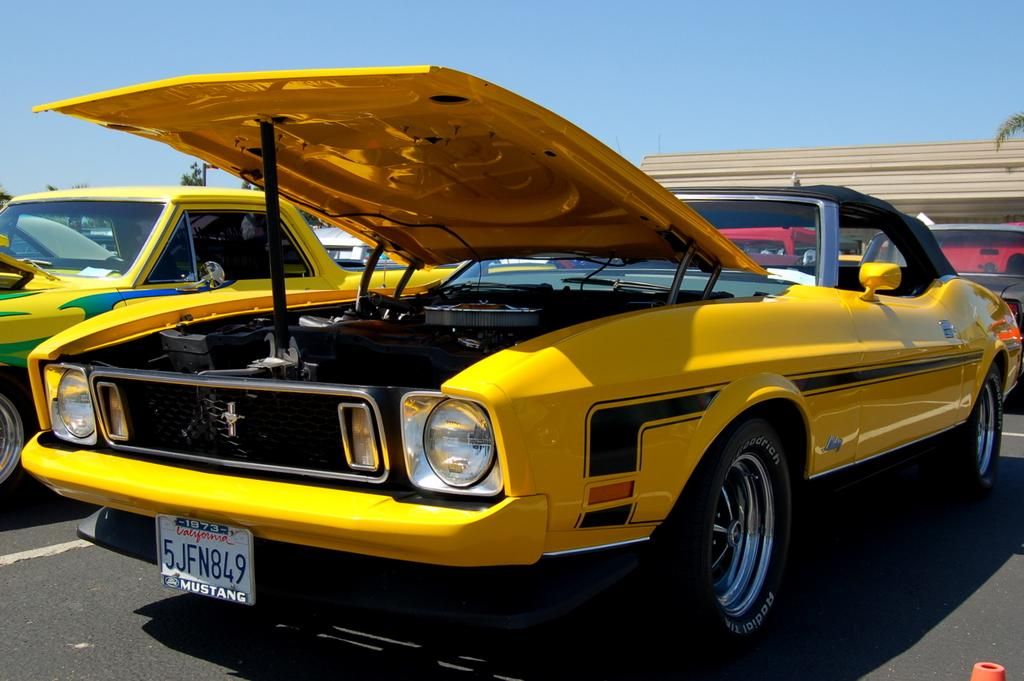<image>
Describe the image concisely. A yellow mustang with a 1973 California licence plate has its hood propped up at a car show. 